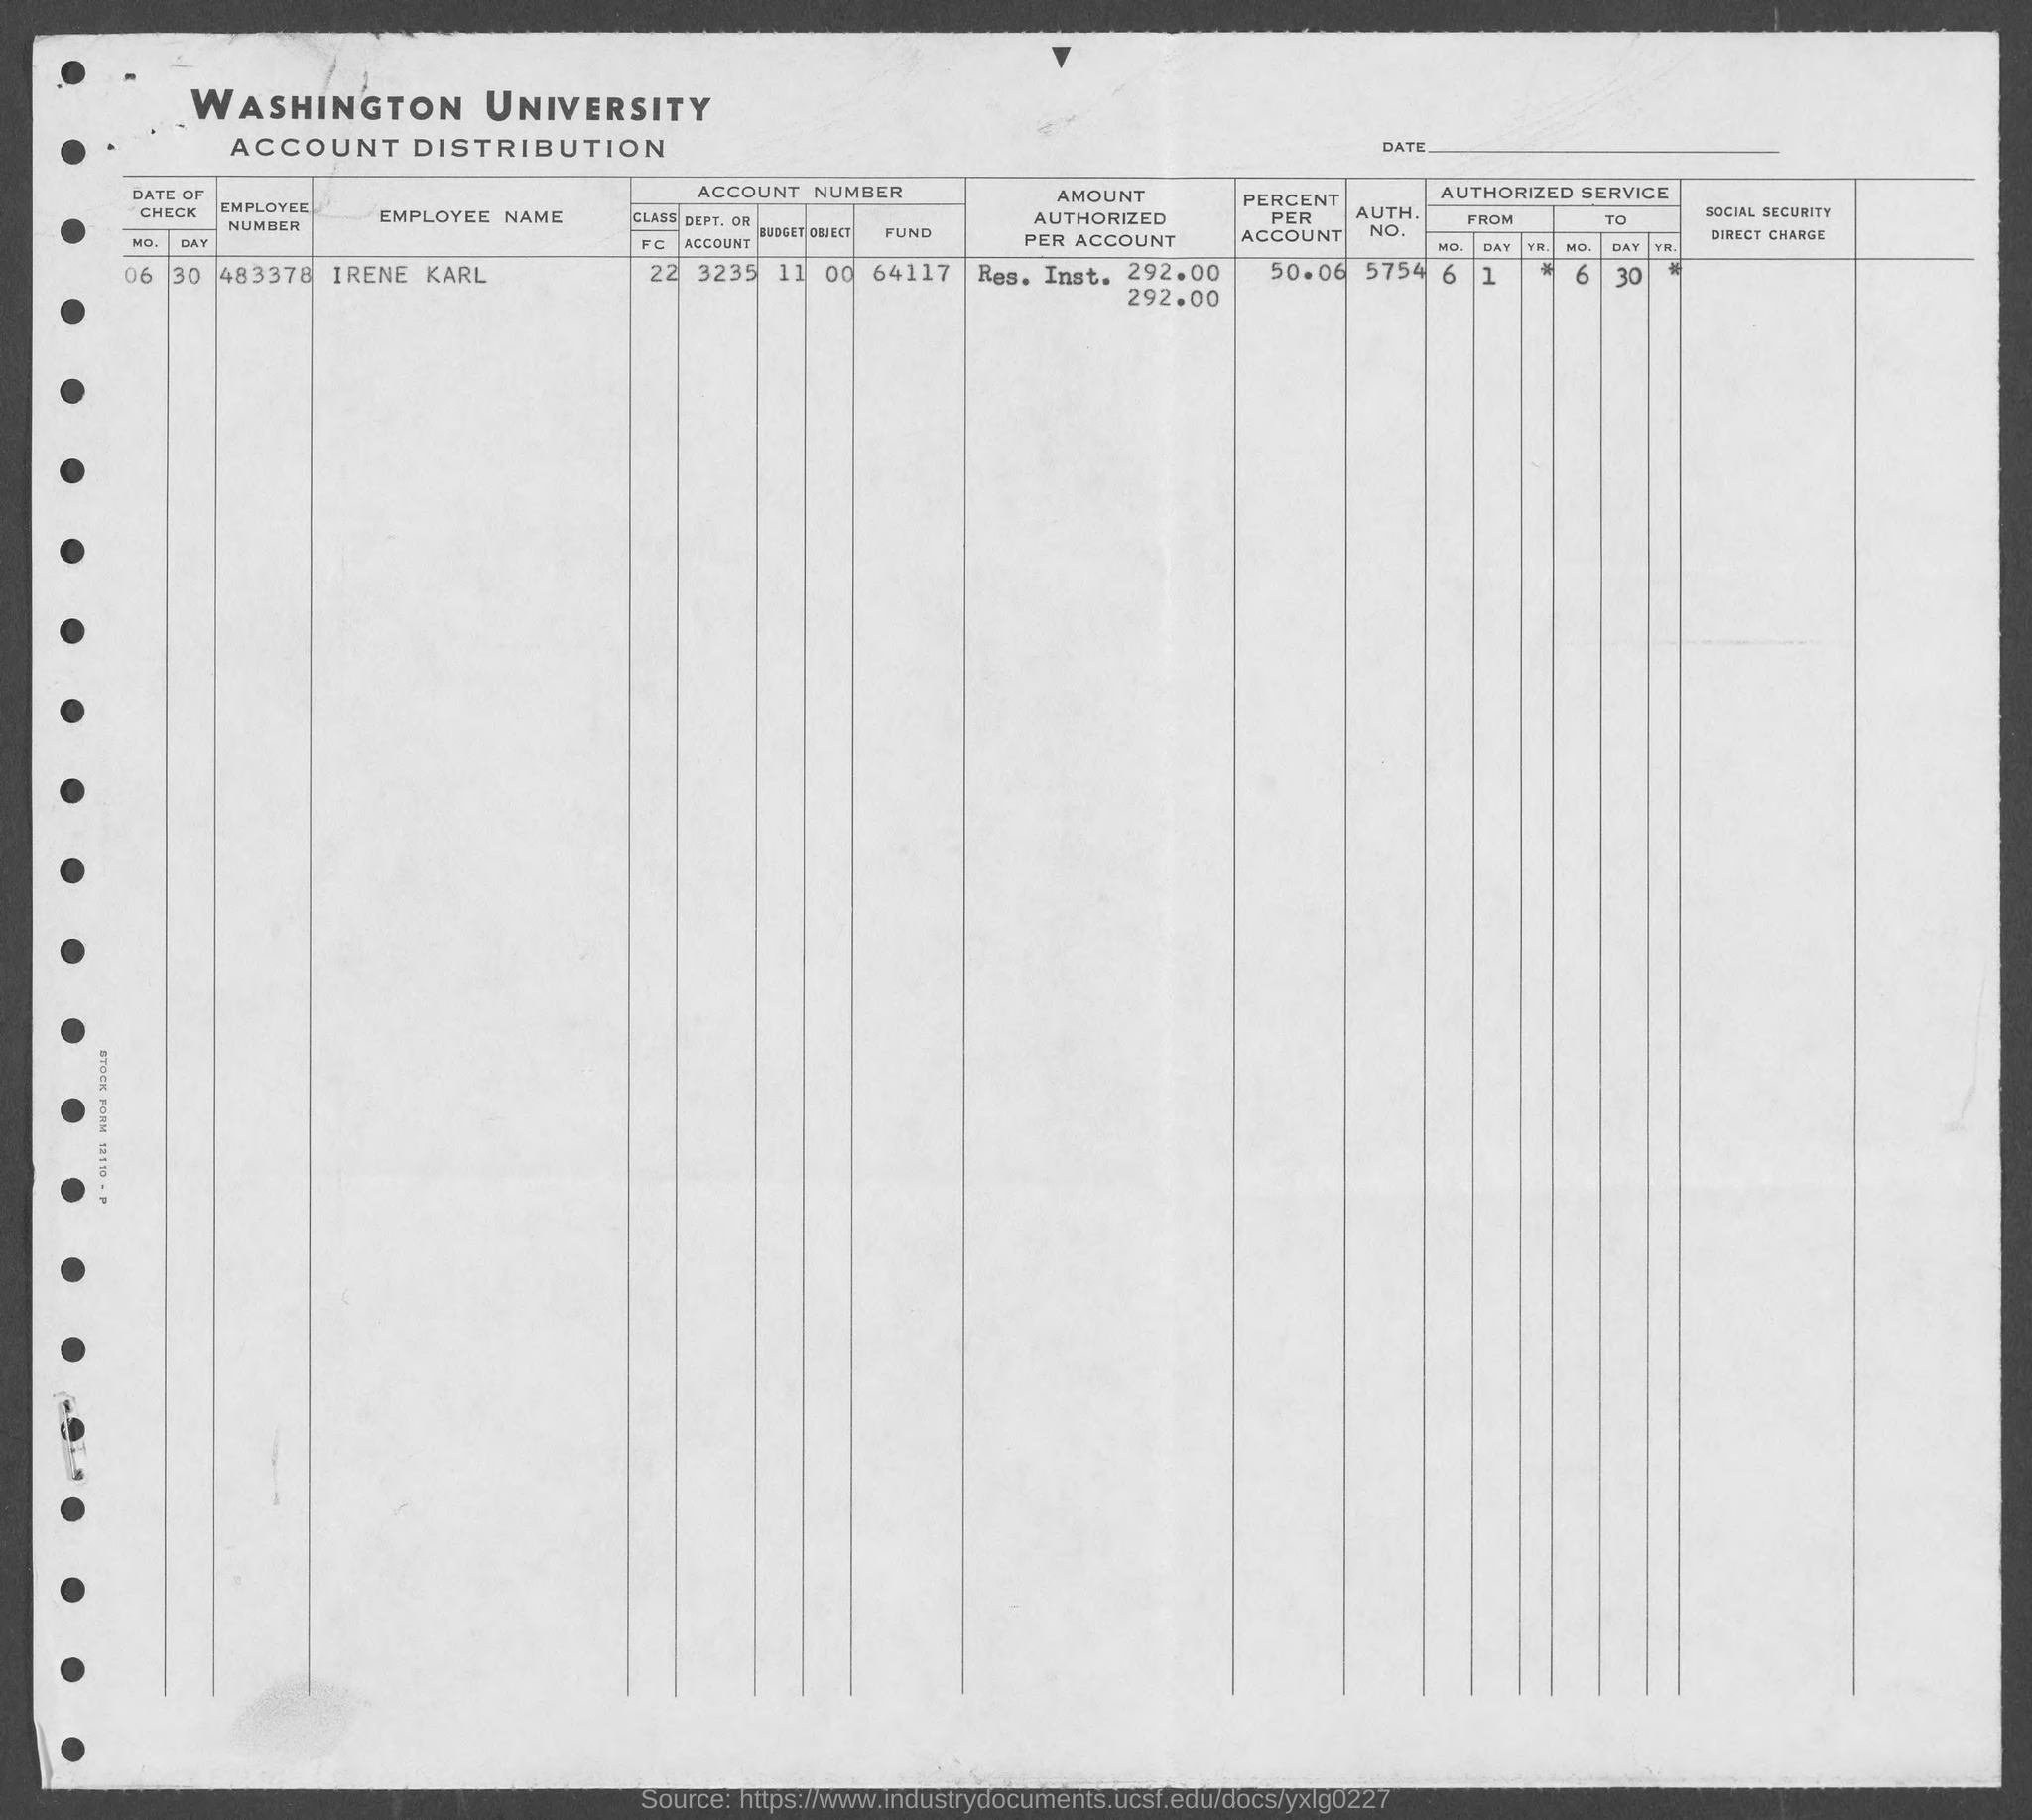Mention a couple of crucial points in this snapshot. The value of the amount authorized per account is 292.00. The authorized number mentioned in the given form is 5754. What is the employee number mentioned in the given form? It is 483378... The value of "percent per account" was mentioned as 50.06 in the given form. The employee name mentioned in the given form is Irene Karl. 